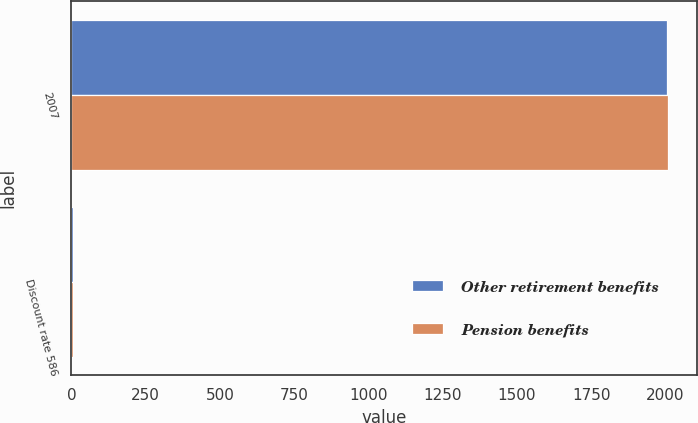Convert chart. <chart><loc_0><loc_0><loc_500><loc_500><stacked_bar_chart><ecel><fcel>2007<fcel>Discount rate 586<nl><fcel>Other retirement benefits<fcel>2006<fcel>5.52<nl><fcel>Pension benefits<fcel>2007<fcel>5.7<nl></chart> 